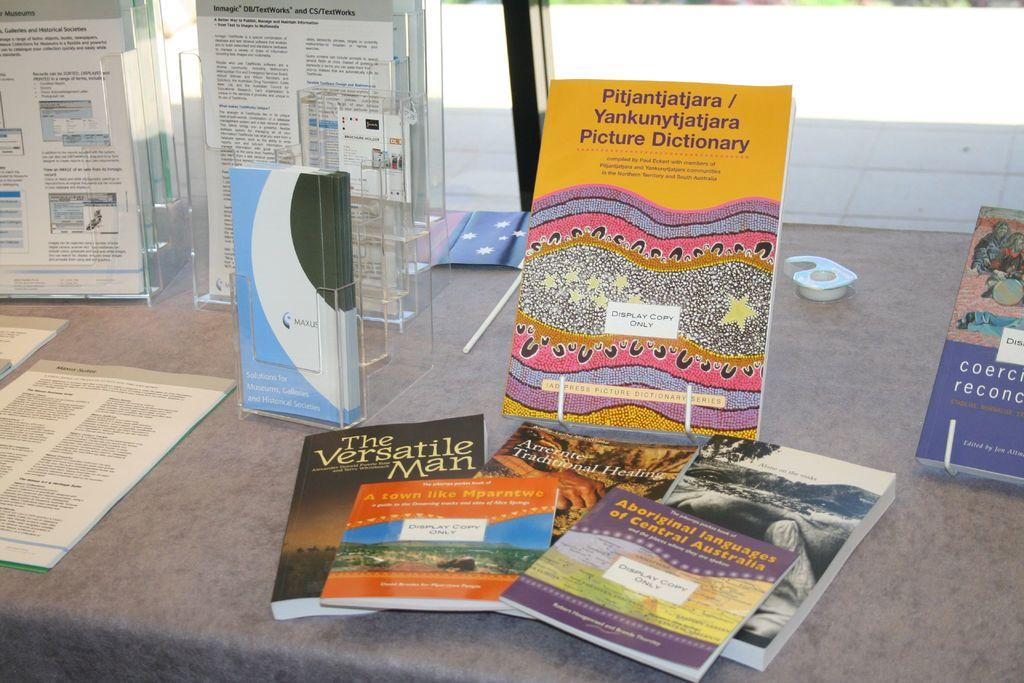<image>
Summarize the visual content of the image. Yellow book on display named "Pitjantjatjara picture dictionary". 